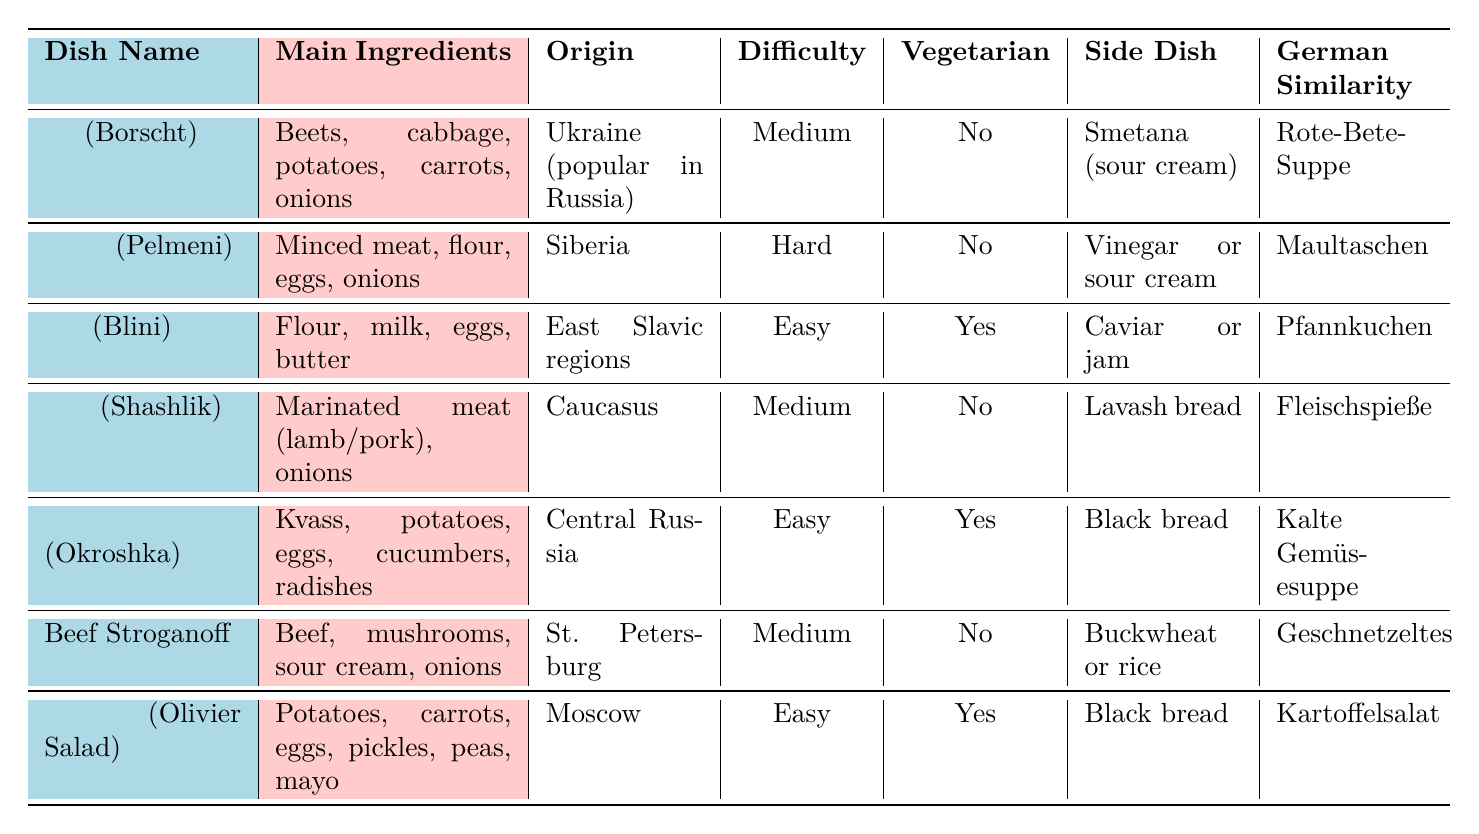What is the main ingredient of Блины (Blini)? The table states that the main ingredients of Блины (Blini) are flour, milk, eggs, and butter.
Answer: Flour, milk, eggs, butter Which dish is vegetarian-friendly? By looking at the "Vegetarian" column, Окрошка (Okroshka) and Блины (Blini) are marked as vegetarian-friendly (Yes).
Answer: Окрошка, Блины What is the region of origin for Салат Оливье? The table indicates that Салат Оливье originates from Moscow.
Answer: Moscow How many dishes are classified as difficult? In the table, only Пельмени (Pelmeni) is labeled with a difficulty level of Hard. Therefore, there is one difficult dish.
Answer: 1 Which dish has a common side dish of black bread? The dishes labeled with black bread as a common side dish are Окрошка (Okroshka) and Салат Оливье (Olivier Salad).
Answer: Окрошка, Салат Оливье How many dishes originate from the Caucasus region? The table shows that only Шашлык (Shashlik) is from the Caucasus region, indicating there is one dish from there.
Answer: 1 Is Beef Stroganoff vegetarian-friendly? The table indicates that Beef Stroganoff is marked as No in the Vegetarian column, so it is not vegetarian-friendly.
Answer: No Which dish has a German similarity of "Maultaschen"? Referring to the table, the dish with a German similarity of "Maultaschen" is Пельмени (Pelmeni).
Answer: Пельмени What is the difficulty level of Окрошка? The table shows that the difficulty level for Окрошка (Okroshka) is Easy.
Answer: Easy Which dish is similar to "Rote-Bete-Suppe"? The table specifies that Борщ (Borscht) has a German similarity of "Rote-Bete-Suppe."
Answer: Борщ 